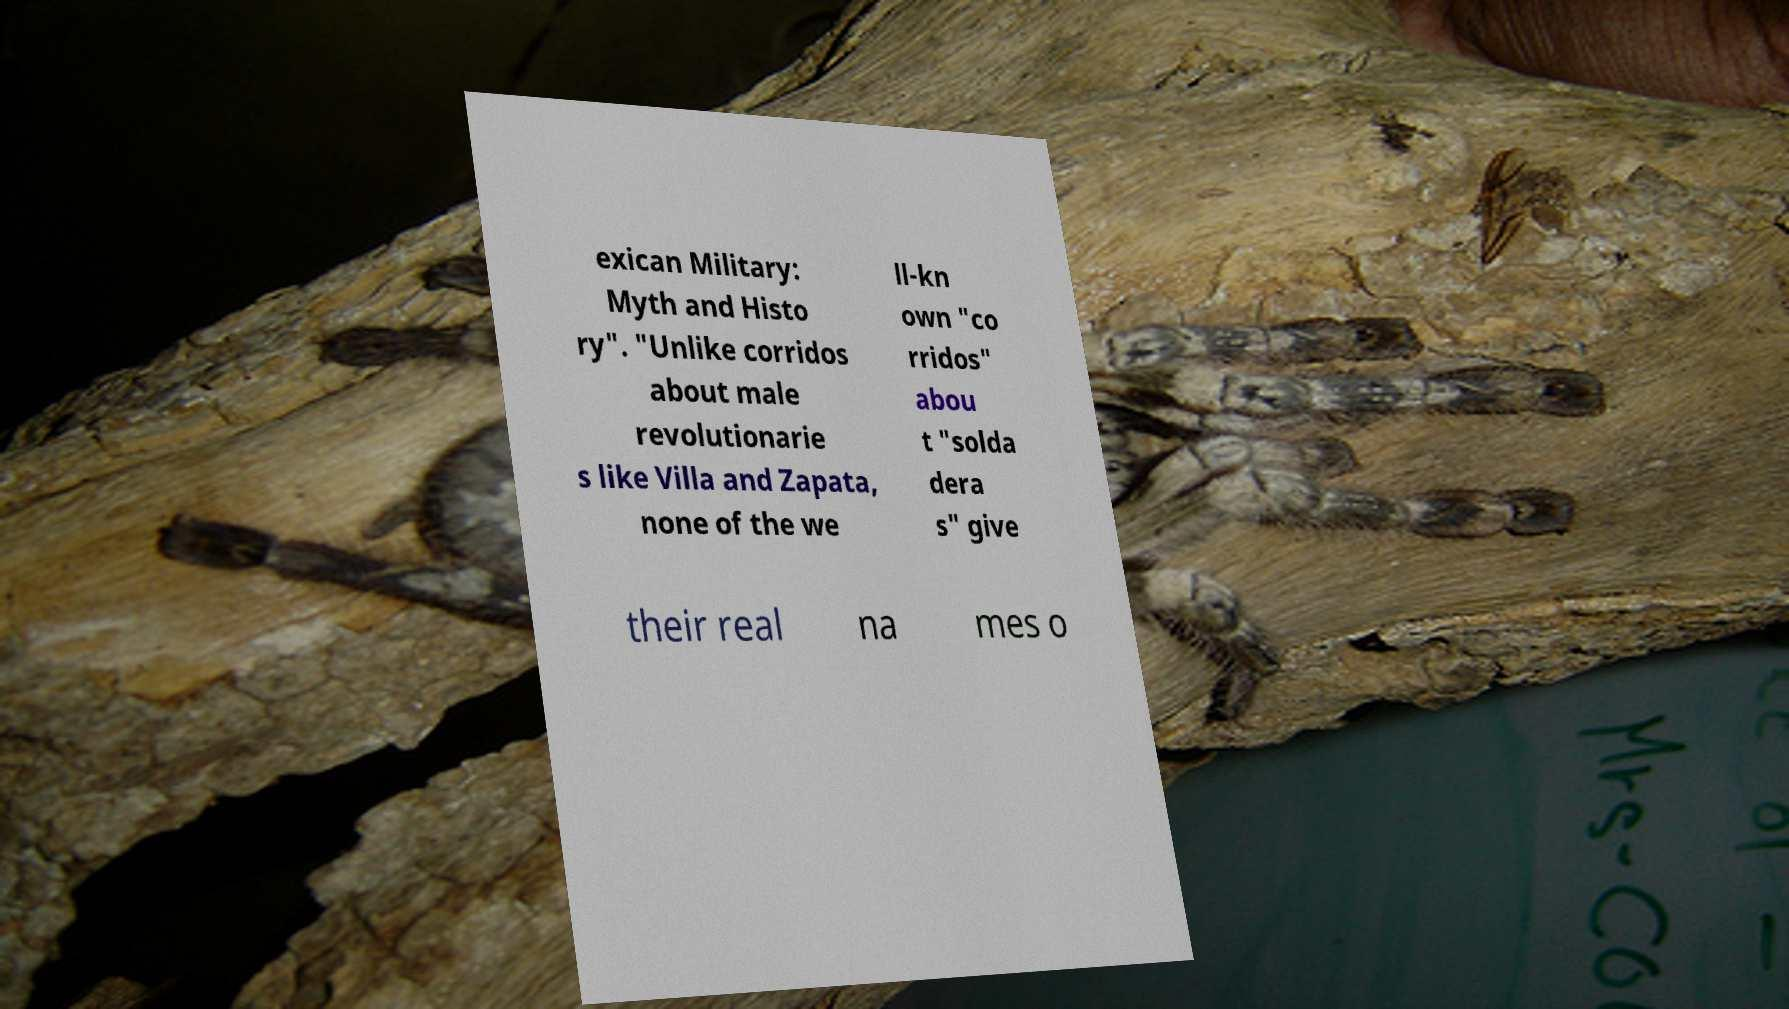What messages or text are displayed in this image? I need them in a readable, typed format. exican Military: Myth and Histo ry". "Unlike corridos about male revolutionarie s like Villa and Zapata, none of the we ll-kn own "co rridos" abou t "solda dera s" give their real na mes o 